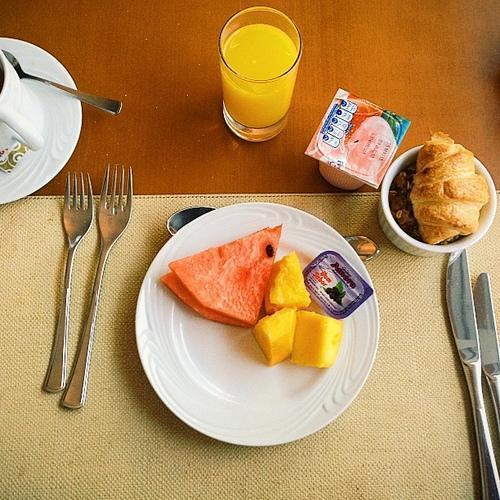How many forks?
Give a very brief answer. 2. How many slices of watermelon?
Give a very brief answer. 2. How many forks are shown?
Give a very brief answer. 2. How many slices of watermelon are there?
Give a very brief answer. 2. 